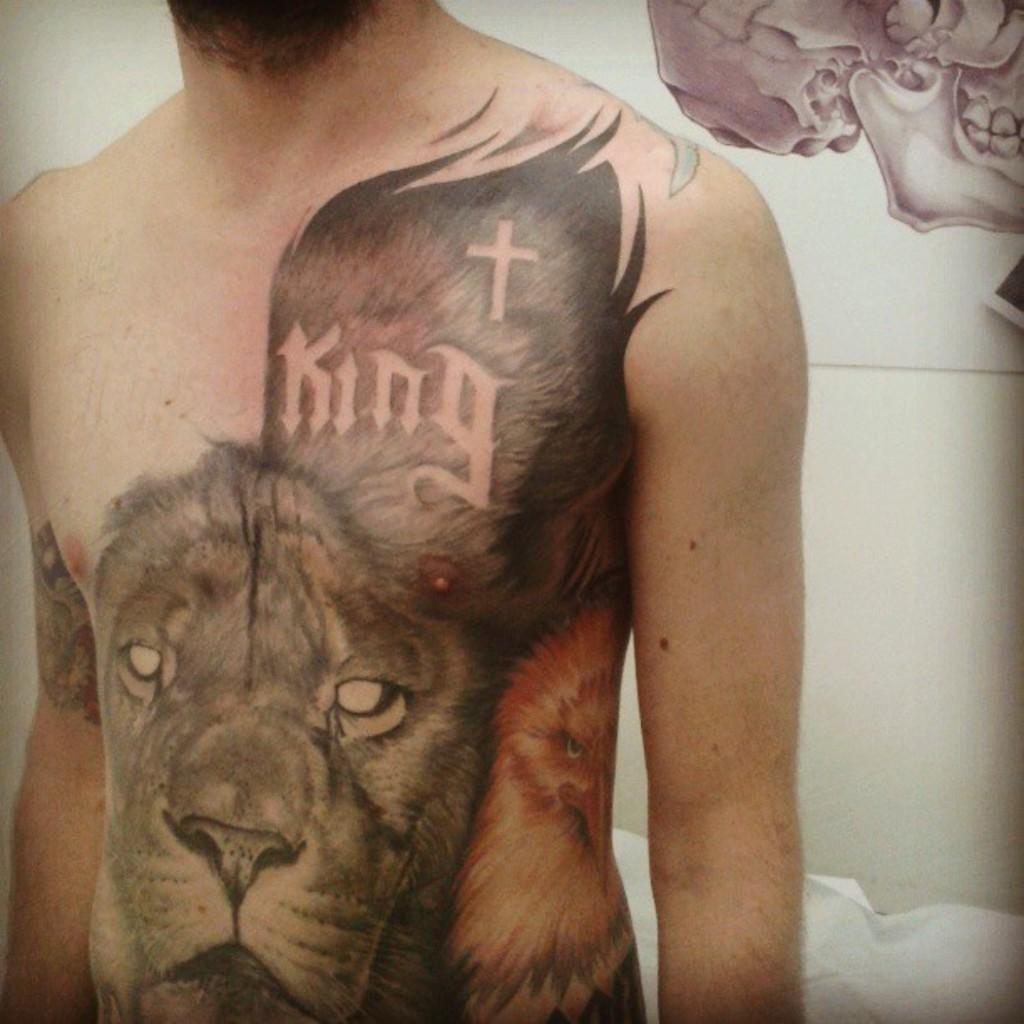What is the main subject of the image? There is a man in the image. Can you describe any distinguishing features of the man? The man has tattoos. What can be seen on the wall behind the man? There appears to be a painting on the wall behind the man. What is the man's desire for his tongue and toe in the image? There is no indication of the man's desires or any mention of his tongue or toe in the image. 